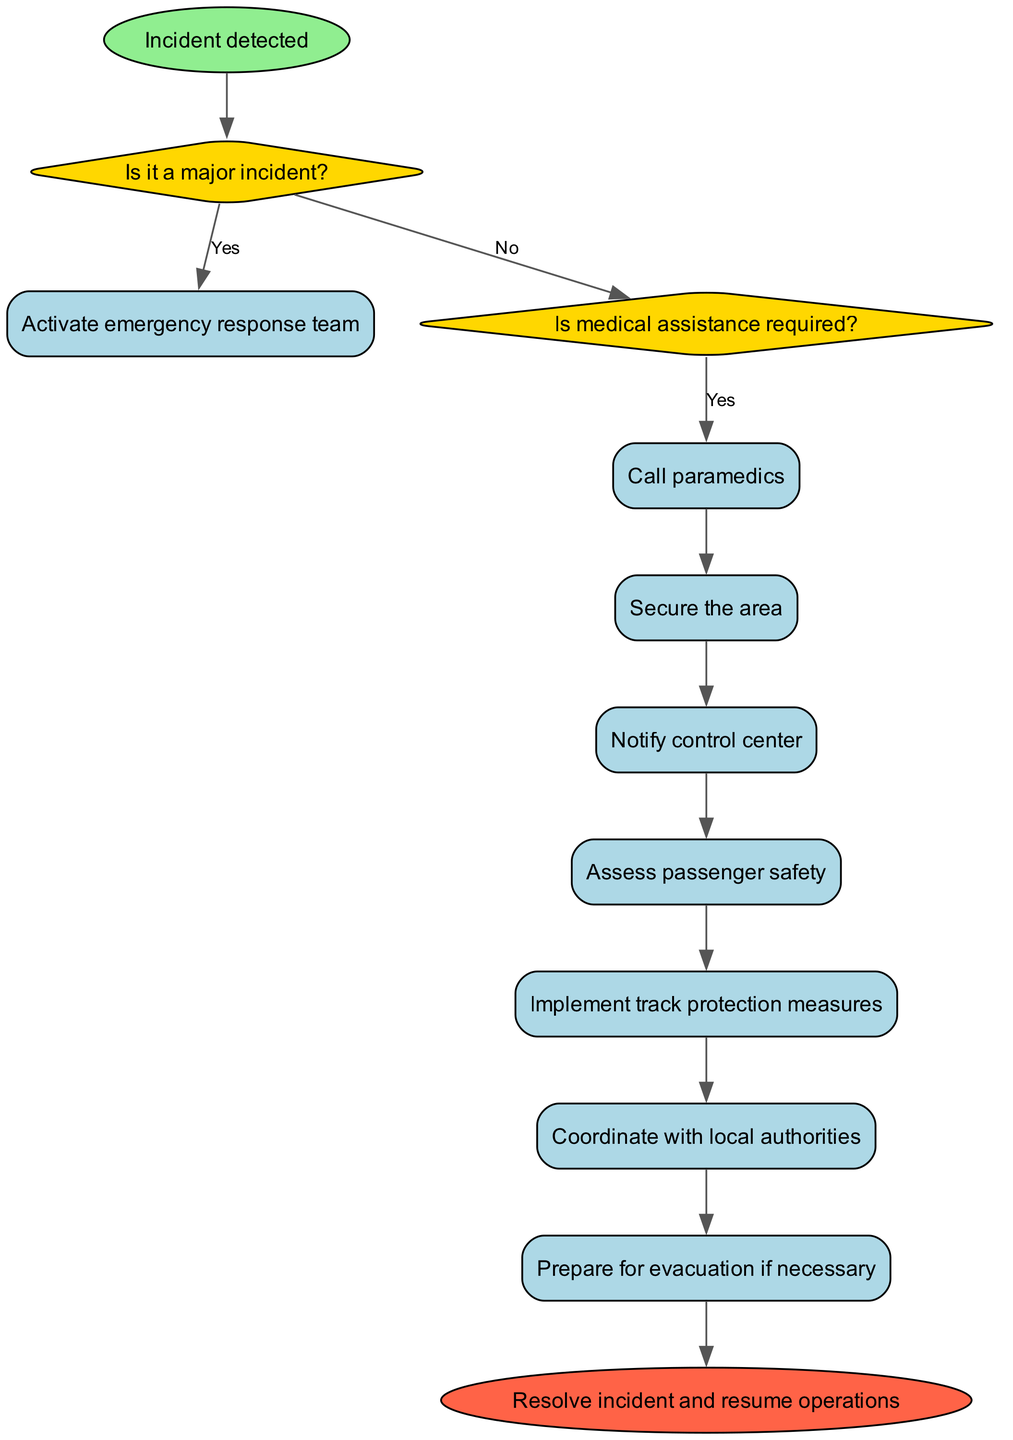What is the starting point of the flowchart? The starting point of the flowchart is labeled "Incident detected," and it is the first node from which all actions and decisions stem.
Answer: Incident detected How many decision nodes are present in the diagram? There are two decision nodes in the diagram: one for determining if it's a major incident and another for whether medical assistance is required.
Answer: 2 What action follows after "Call paramedics"? The action that immediately follows "Call paramedics" is "Proceed with assessment," indicating what happens next in the protocol.
Answer: Proceed with assessment What will happen if the incident is not a major incident? If the incident is not a major incident, the protocol indicates to "Handle locally," which refers to a localized response rather than a full emergency response.
Answer: Handle locally Which node leads to the end of the process? The last action node in the flowchart, "Prepare for evacuation if necessary," directs the flow to the end node, which states "Resolve incident and resume operations."
Answer: Resolve incident and resume operations If medical assistance is not required, which action comes next? After determining that medical assistance is not required, the next step in the flowchart is "Proceed with assessment," indicating a shift to assessing the situation.
Answer: Proceed with assessment What color is used for decision nodes? The decision nodes in the flowchart are filled with a light gold color, signifying their distinct function in the diagram related to making choices.
Answer: Light gold How many total actions are listed in the diagram? There are a total of six action nodes listed in the diagram, each representing a specific task to perform during the response protocol.
Answer: 6 What is the second decision condition in the flowchart? The second decision condition in the flowchart is "Is medical assistance required?", which guides the subsequent actions based on the need for medical help.
Answer: Is medical assistance required? 